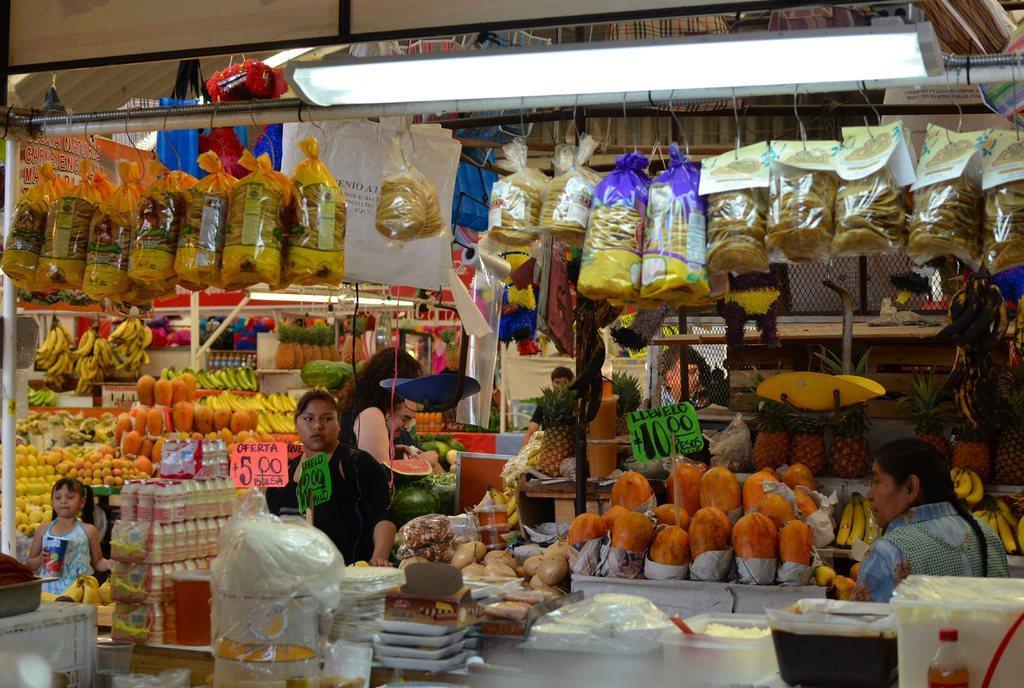How would you summarize this image in a sentence or two? In this picture we can see many fruits, bottles, plates, bowls and food packets on top. There are few bags on top. We can see few number boards. Few people are visible. There is a tube light on top. 